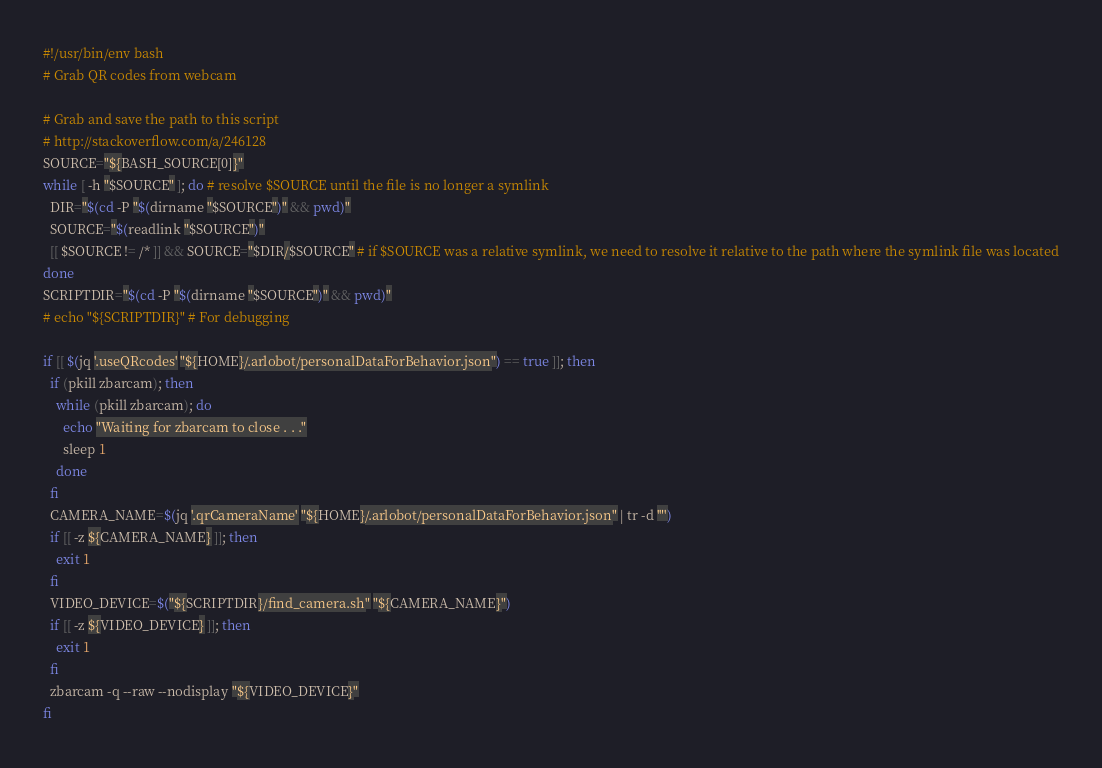Convert code to text. <code><loc_0><loc_0><loc_500><loc_500><_Bash_>#!/usr/bin/env bash
# Grab QR codes from webcam

# Grab and save the path to this script
# http://stackoverflow.com/a/246128
SOURCE="${BASH_SOURCE[0]}"
while [ -h "$SOURCE" ]; do # resolve $SOURCE until the file is no longer a symlink
  DIR="$(cd -P "$(dirname "$SOURCE")" && pwd)"
  SOURCE="$(readlink "$SOURCE")"
  [[ $SOURCE != /* ]] && SOURCE="$DIR/$SOURCE" # if $SOURCE was a relative symlink, we need to resolve it relative to the path where the symlink file was located
done
SCRIPTDIR="$(cd -P "$(dirname "$SOURCE")" && pwd)"
# echo "${SCRIPTDIR}" # For debugging

if [[ $(jq '.useQRcodes' "${HOME}/.arlobot/personalDataForBehavior.json") == true ]]; then
  if (pkill zbarcam); then
    while (pkill zbarcam); do
      echo "Waiting for zbarcam to close . . ."
      sleep 1
    done
  fi
  CAMERA_NAME=$(jq '.qrCameraName' "${HOME}/.arlobot/personalDataForBehavior.json" | tr -d '"')
  if [[ -z ${CAMERA_NAME} ]]; then
    exit 1
  fi
  VIDEO_DEVICE=$("${SCRIPTDIR}/find_camera.sh" "${CAMERA_NAME}")
  if [[ -z ${VIDEO_DEVICE} ]]; then
    exit 1
  fi
  zbarcam -q --raw --nodisplay "${VIDEO_DEVICE}"
fi
</code> 